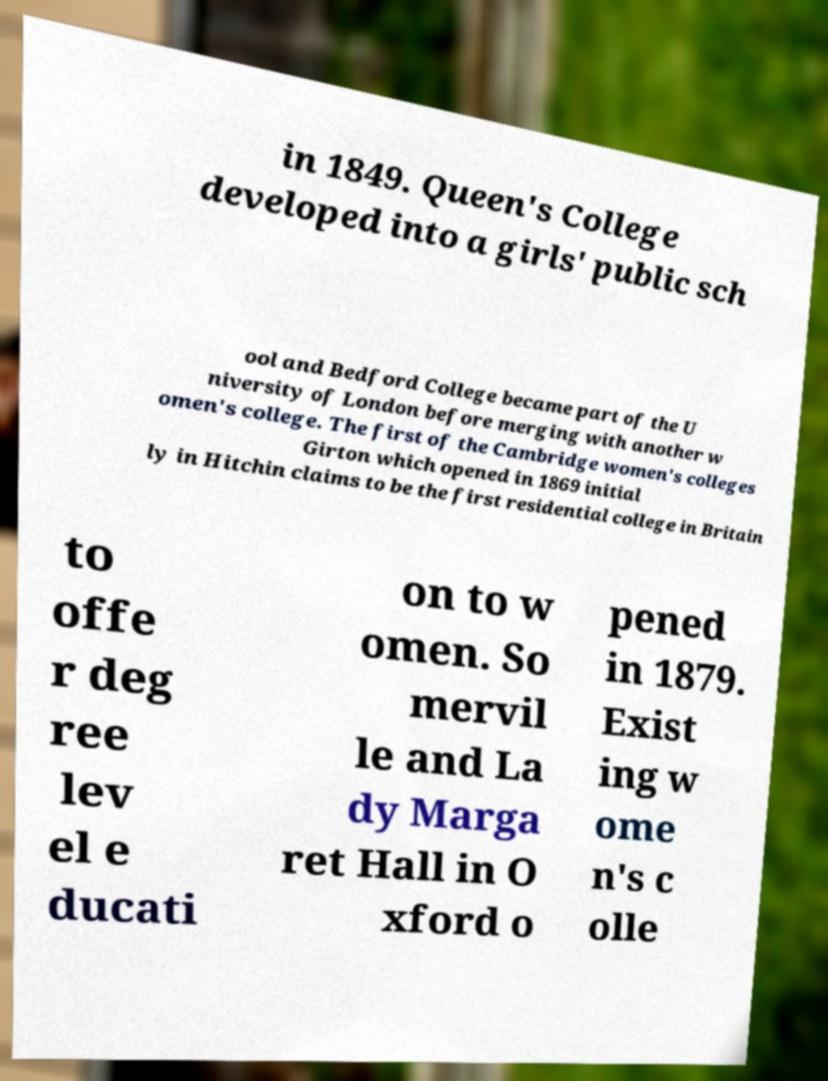I need the written content from this picture converted into text. Can you do that? in 1849. Queen's College developed into a girls' public sch ool and Bedford College became part of the U niversity of London before merging with another w omen's college. The first of the Cambridge women's colleges Girton which opened in 1869 initial ly in Hitchin claims to be the first residential college in Britain to offe r deg ree lev el e ducati on to w omen. So mervil le and La dy Marga ret Hall in O xford o pened in 1879. Exist ing w ome n's c olle 